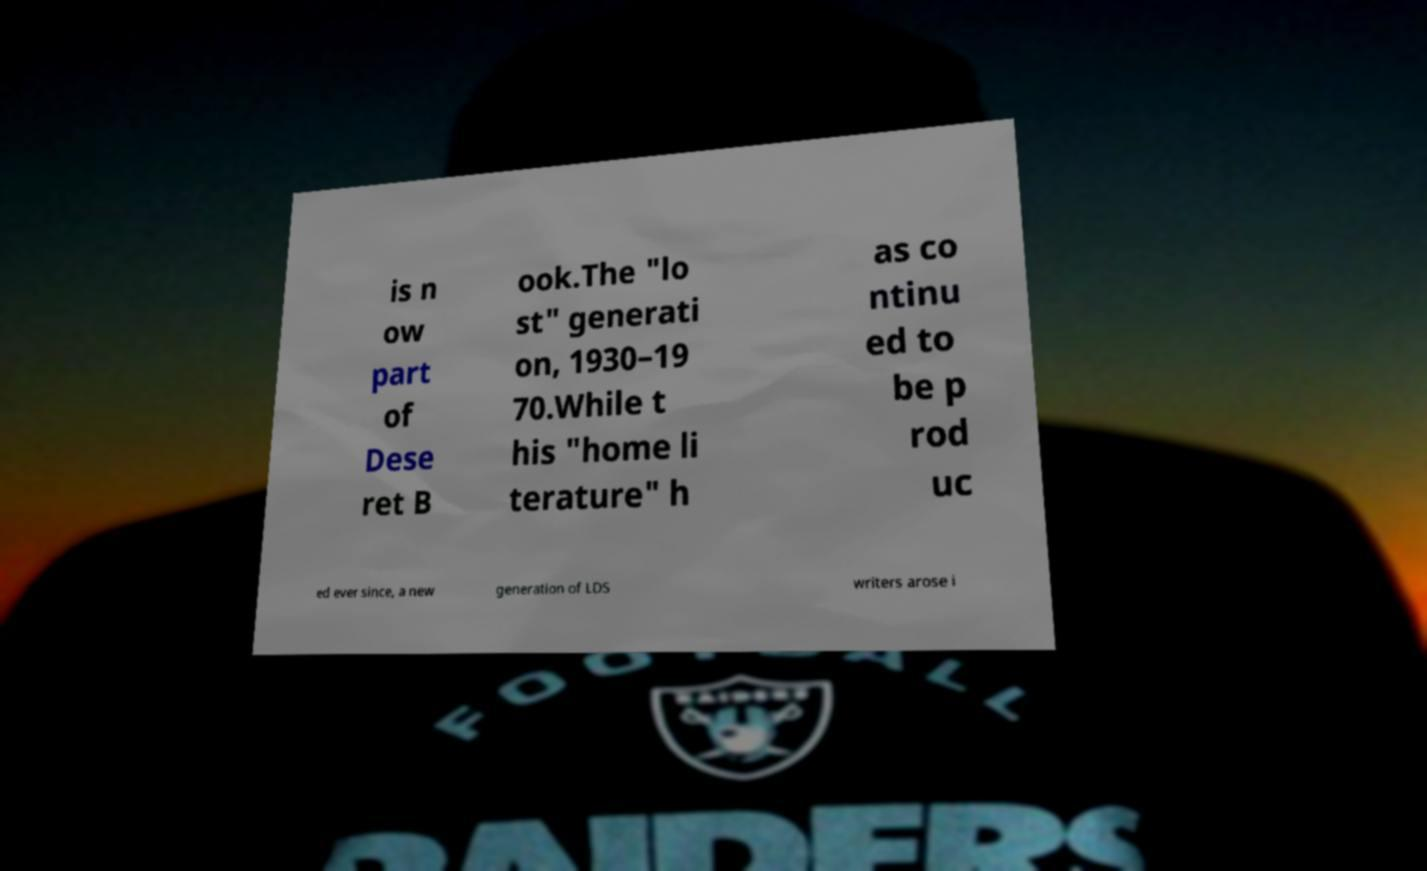Please read and relay the text visible in this image. What does it say? is n ow part of Dese ret B ook.The "lo st" generati on, 1930–19 70.While t his "home li terature" h as co ntinu ed to be p rod uc ed ever since, a new generation of LDS writers arose i 